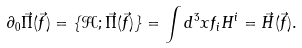Convert formula to latex. <formula><loc_0><loc_0><loc_500><loc_500>\partial _ { 0 } \vec { \Pi } ( \vec { f } ) = \{ \mathcal { H } ; \vec { \Pi } ( \vec { f } ) \} = \int d ^ { 3 } x f _ { i } H ^ { i } = \vec { H } ( \vec { f } ) .</formula> 